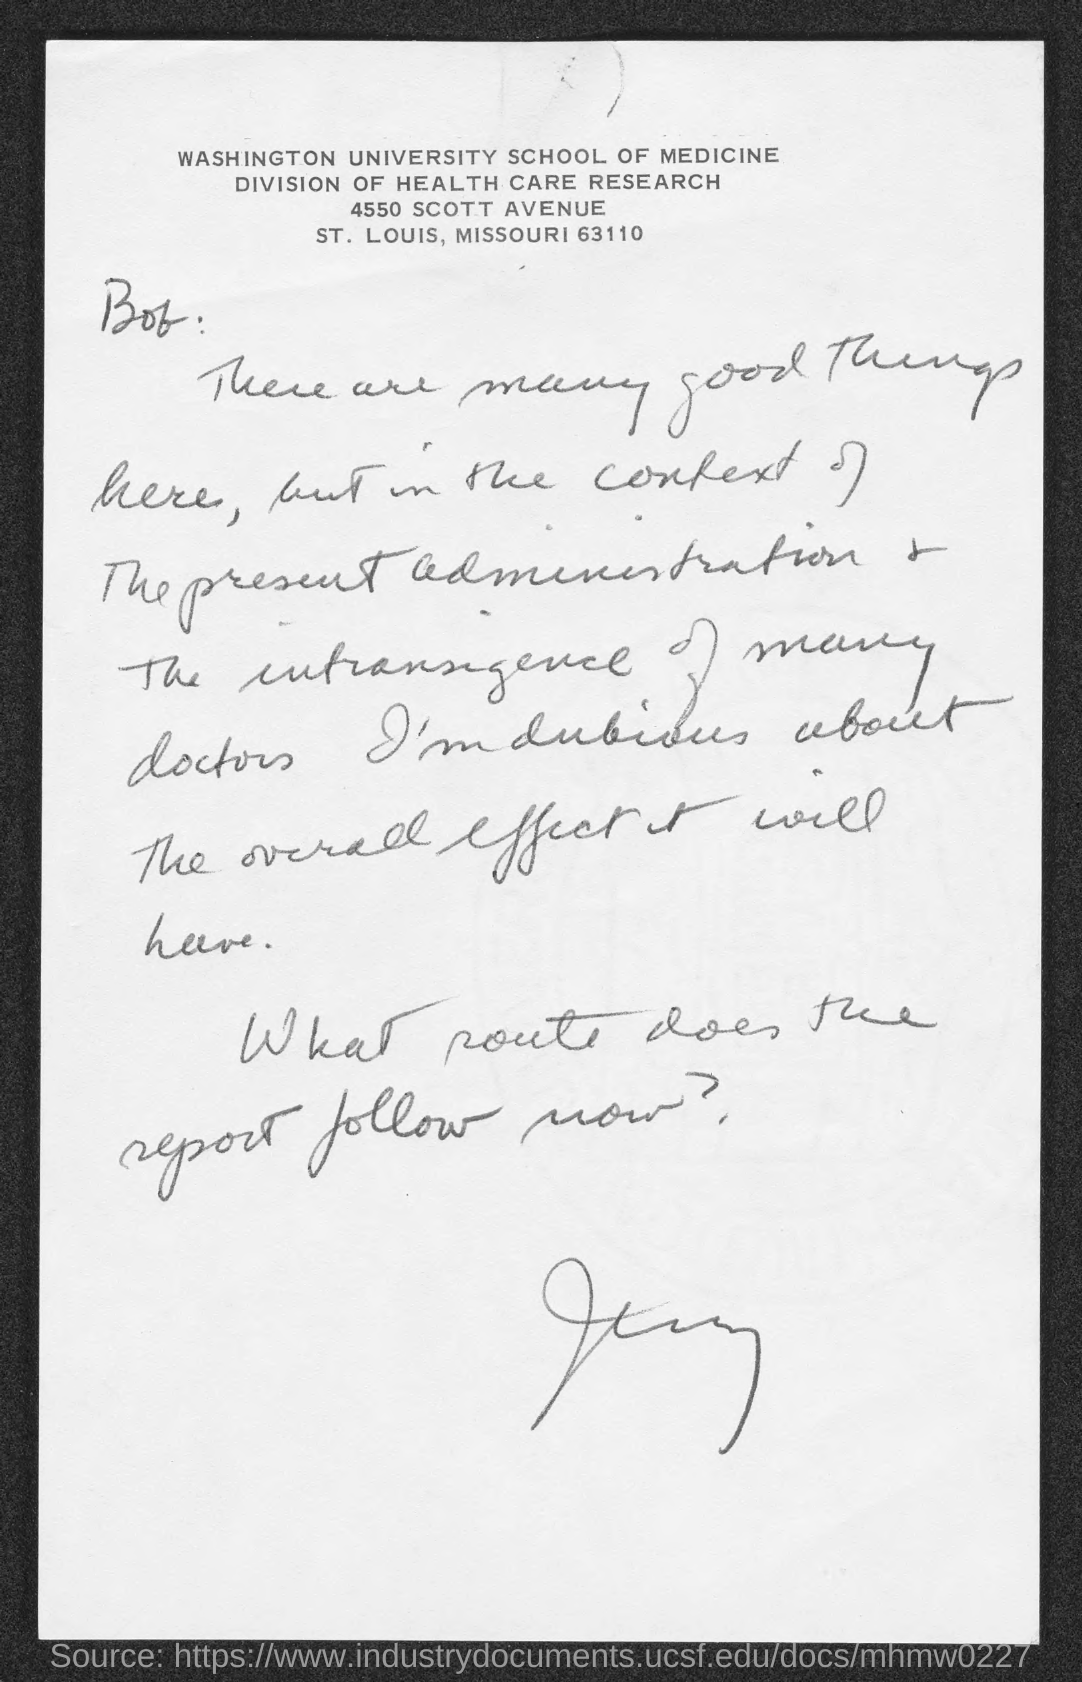Identify some key points in this picture. Washington University is mentioned in the header of the document. 